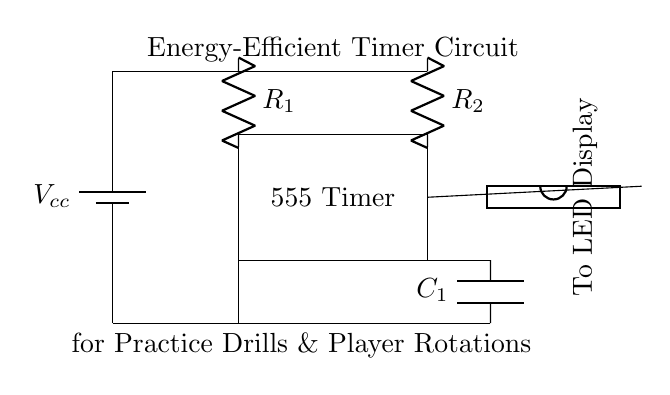What is the main component used for timing in this circuit? The main timing component in this circuit is the 555 Timer, which is responsible for generating a precise time interval for the player rotations during practice drills.
Answer: 555 Timer What does R_1 and R_2 influence in the circuit? Resistors R_1 and R_2 together determine the timing interval of the 555 Timer by affecting the charge and discharge time of the capacitor, thus influencing how long the output signal stays high or low.
Answer: Timing interval What is the role of C_1 in this circuit? Capacitor C_1 stores energy and releases it during the timing cycle; it plays a crucial role in determining the charging time and, consequently, the timing duration of the timer circuit.
Answer: Timing duration How many pins does the DIP chip have? The DIP chip shown in the circuit is a single pin device, suggesting it connects to the output of the 555 Timer, possibly to drive an indicator or display.
Answer: One pin What is the intended application of this timer circuit? This timer circuit is specifically designed for managing practice drills and player rotations, allowing for efficient timing in a coaching scenario.
Answer: Managing practice drills 